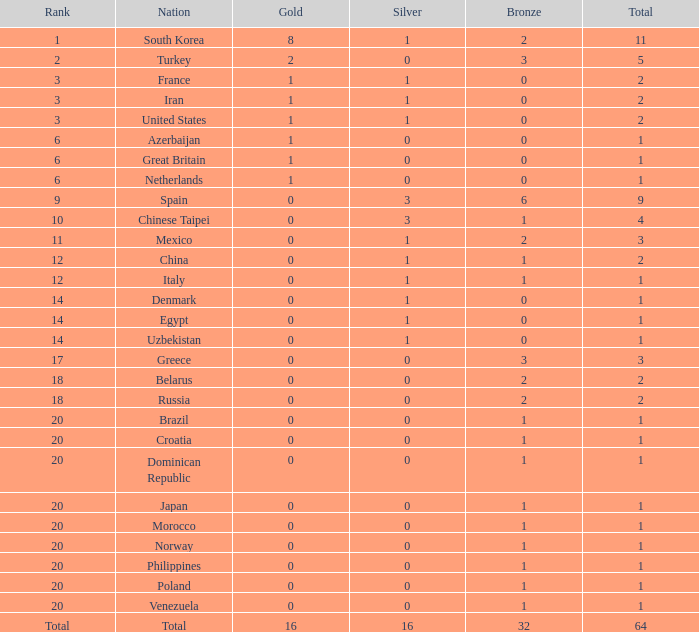What is the typical amount of bronze of the nation possessing more than one gold and one silver medal? 2.0. 